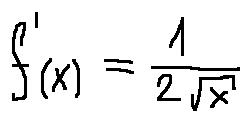Convert formula to latex. <formula><loc_0><loc_0><loc_500><loc_500>f ^ { \prime } ( x ) = \frac { 1 } { 2 \sqrt { x } }</formula> 